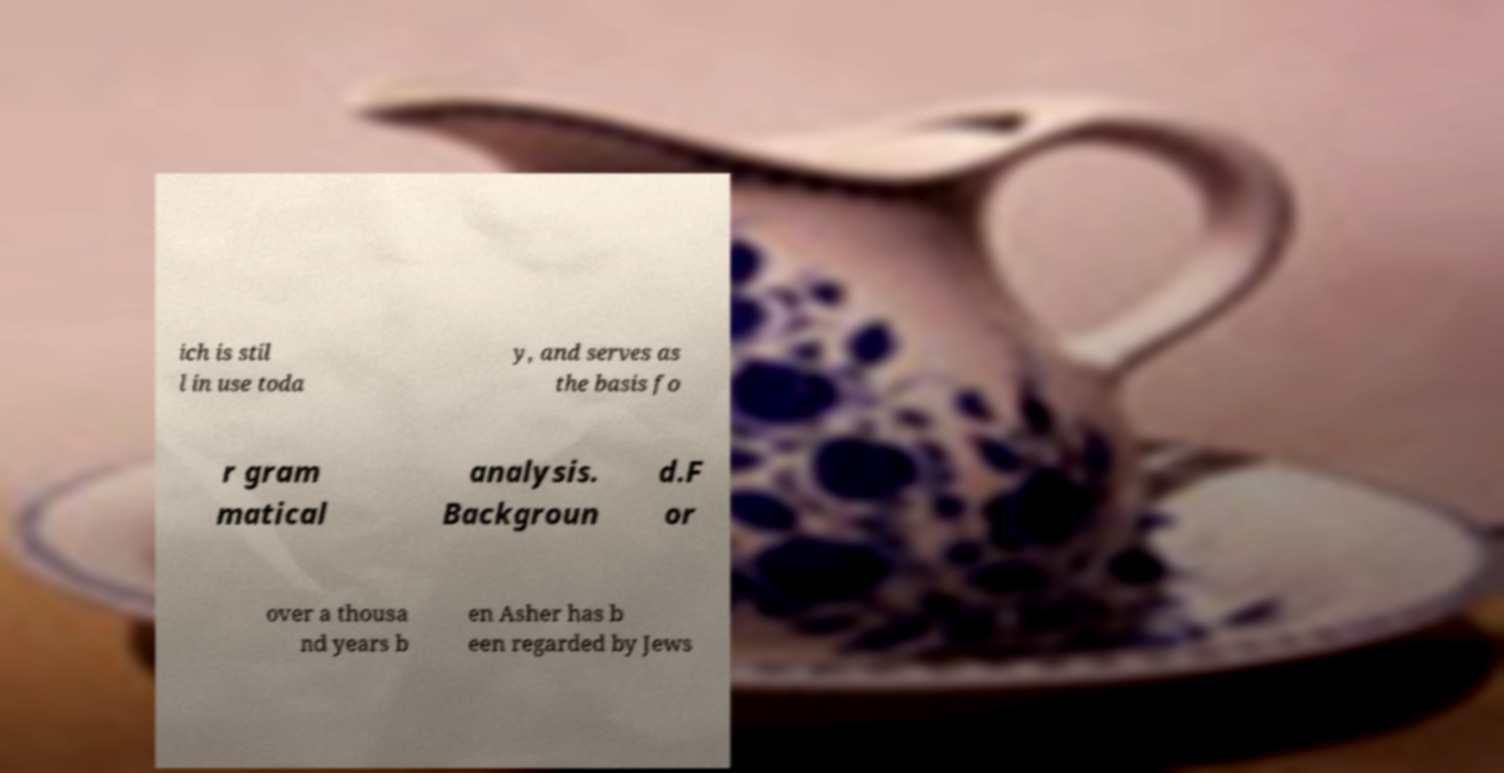Please identify and transcribe the text found in this image. ich is stil l in use toda y, and serves as the basis fo r gram matical analysis. Backgroun d.F or over a thousa nd years b en Asher has b een regarded by Jews 